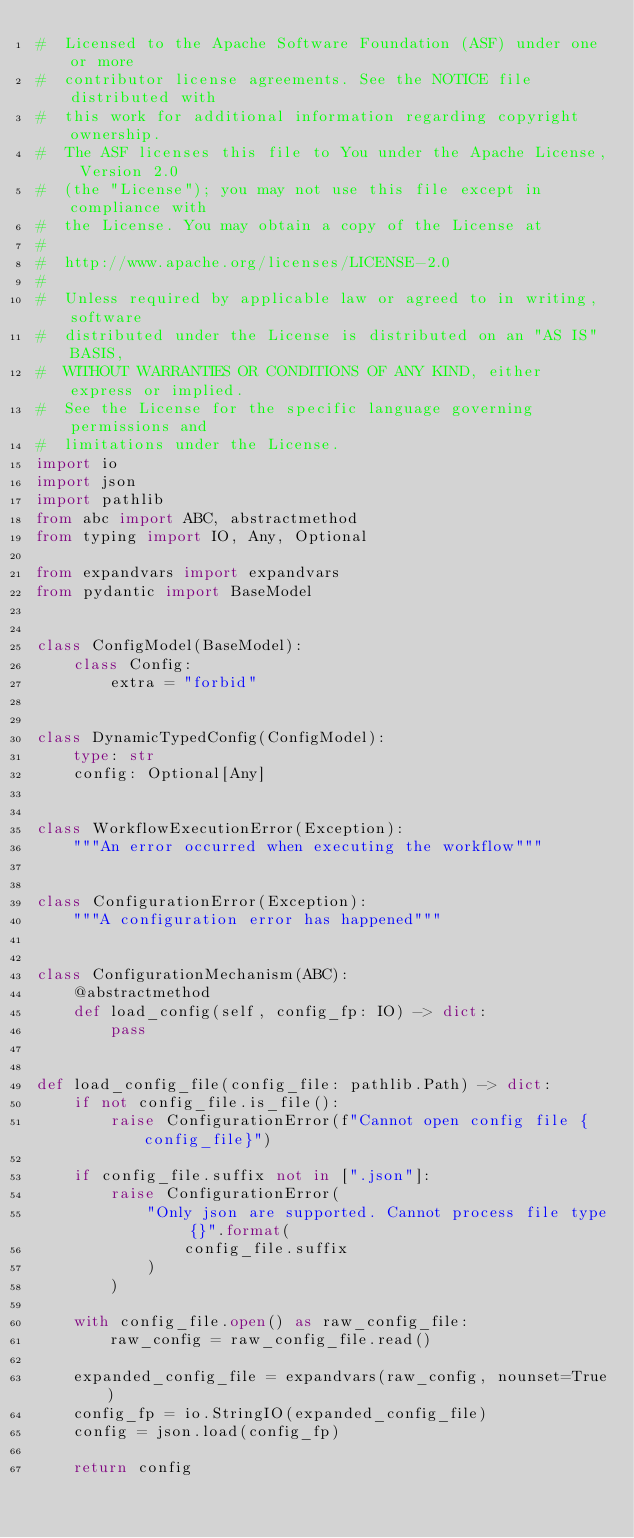Convert code to text. <code><loc_0><loc_0><loc_500><loc_500><_Python_>#  Licensed to the Apache Software Foundation (ASF) under one or more
#  contributor license agreements. See the NOTICE file distributed with
#  this work for additional information regarding copyright ownership.
#  The ASF licenses this file to You under the Apache License, Version 2.0
#  (the "License"); you may not use this file except in compliance with
#  the License. You may obtain a copy of the License at
#
#  http://www.apache.org/licenses/LICENSE-2.0
#
#  Unless required by applicable law or agreed to in writing, software
#  distributed under the License is distributed on an "AS IS" BASIS,
#  WITHOUT WARRANTIES OR CONDITIONS OF ANY KIND, either express or implied.
#  See the License for the specific language governing permissions and
#  limitations under the License.
import io
import json
import pathlib
from abc import ABC, abstractmethod
from typing import IO, Any, Optional

from expandvars import expandvars
from pydantic import BaseModel


class ConfigModel(BaseModel):
    class Config:
        extra = "forbid"


class DynamicTypedConfig(ConfigModel):
    type: str
    config: Optional[Any]


class WorkflowExecutionError(Exception):
    """An error occurred when executing the workflow"""


class ConfigurationError(Exception):
    """A configuration error has happened"""


class ConfigurationMechanism(ABC):
    @abstractmethod
    def load_config(self, config_fp: IO) -> dict:
        pass


def load_config_file(config_file: pathlib.Path) -> dict:
    if not config_file.is_file():
        raise ConfigurationError(f"Cannot open config file {config_file}")

    if config_file.suffix not in [".json"]:
        raise ConfigurationError(
            "Only json are supported. Cannot process file type {}".format(
                config_file.suffix
            )
        )

    with config_file.open() as raw_config_file:
        raw_config = raw_config_file.read()

    expanded_config_file = expandvars(raw_config, nounset=True)
    config_fp = io.StringIO(expanded_config_file)
    config = json.load(config_fp)

    return config
</code> 